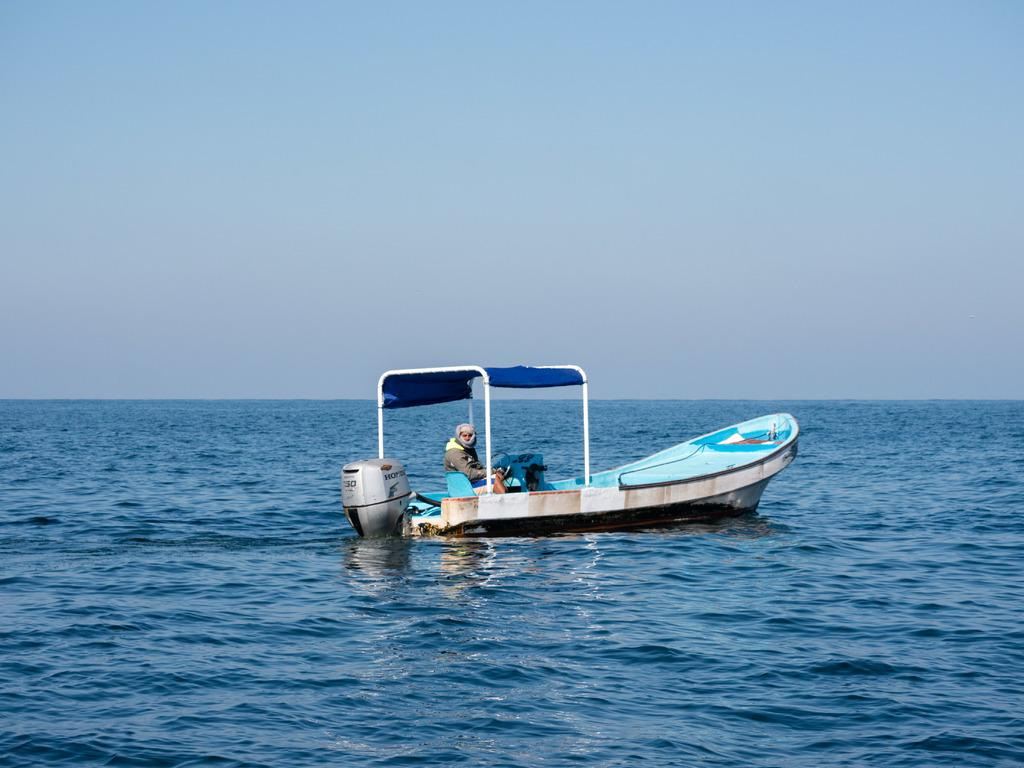What type of boat is in the image? There is a blue and white color boat in the image. Where is the boat located? The boat is on the surface of an ocean. What is the color of the sky in the image? The sky is blue in color. Who is present in the boat? There is a man sitting in the boat. What type of plant is growing in the boat? There is no plant growing in the boat; the image only shows a blue and white color boat on the surface of an ocean with a man sitting in it. 